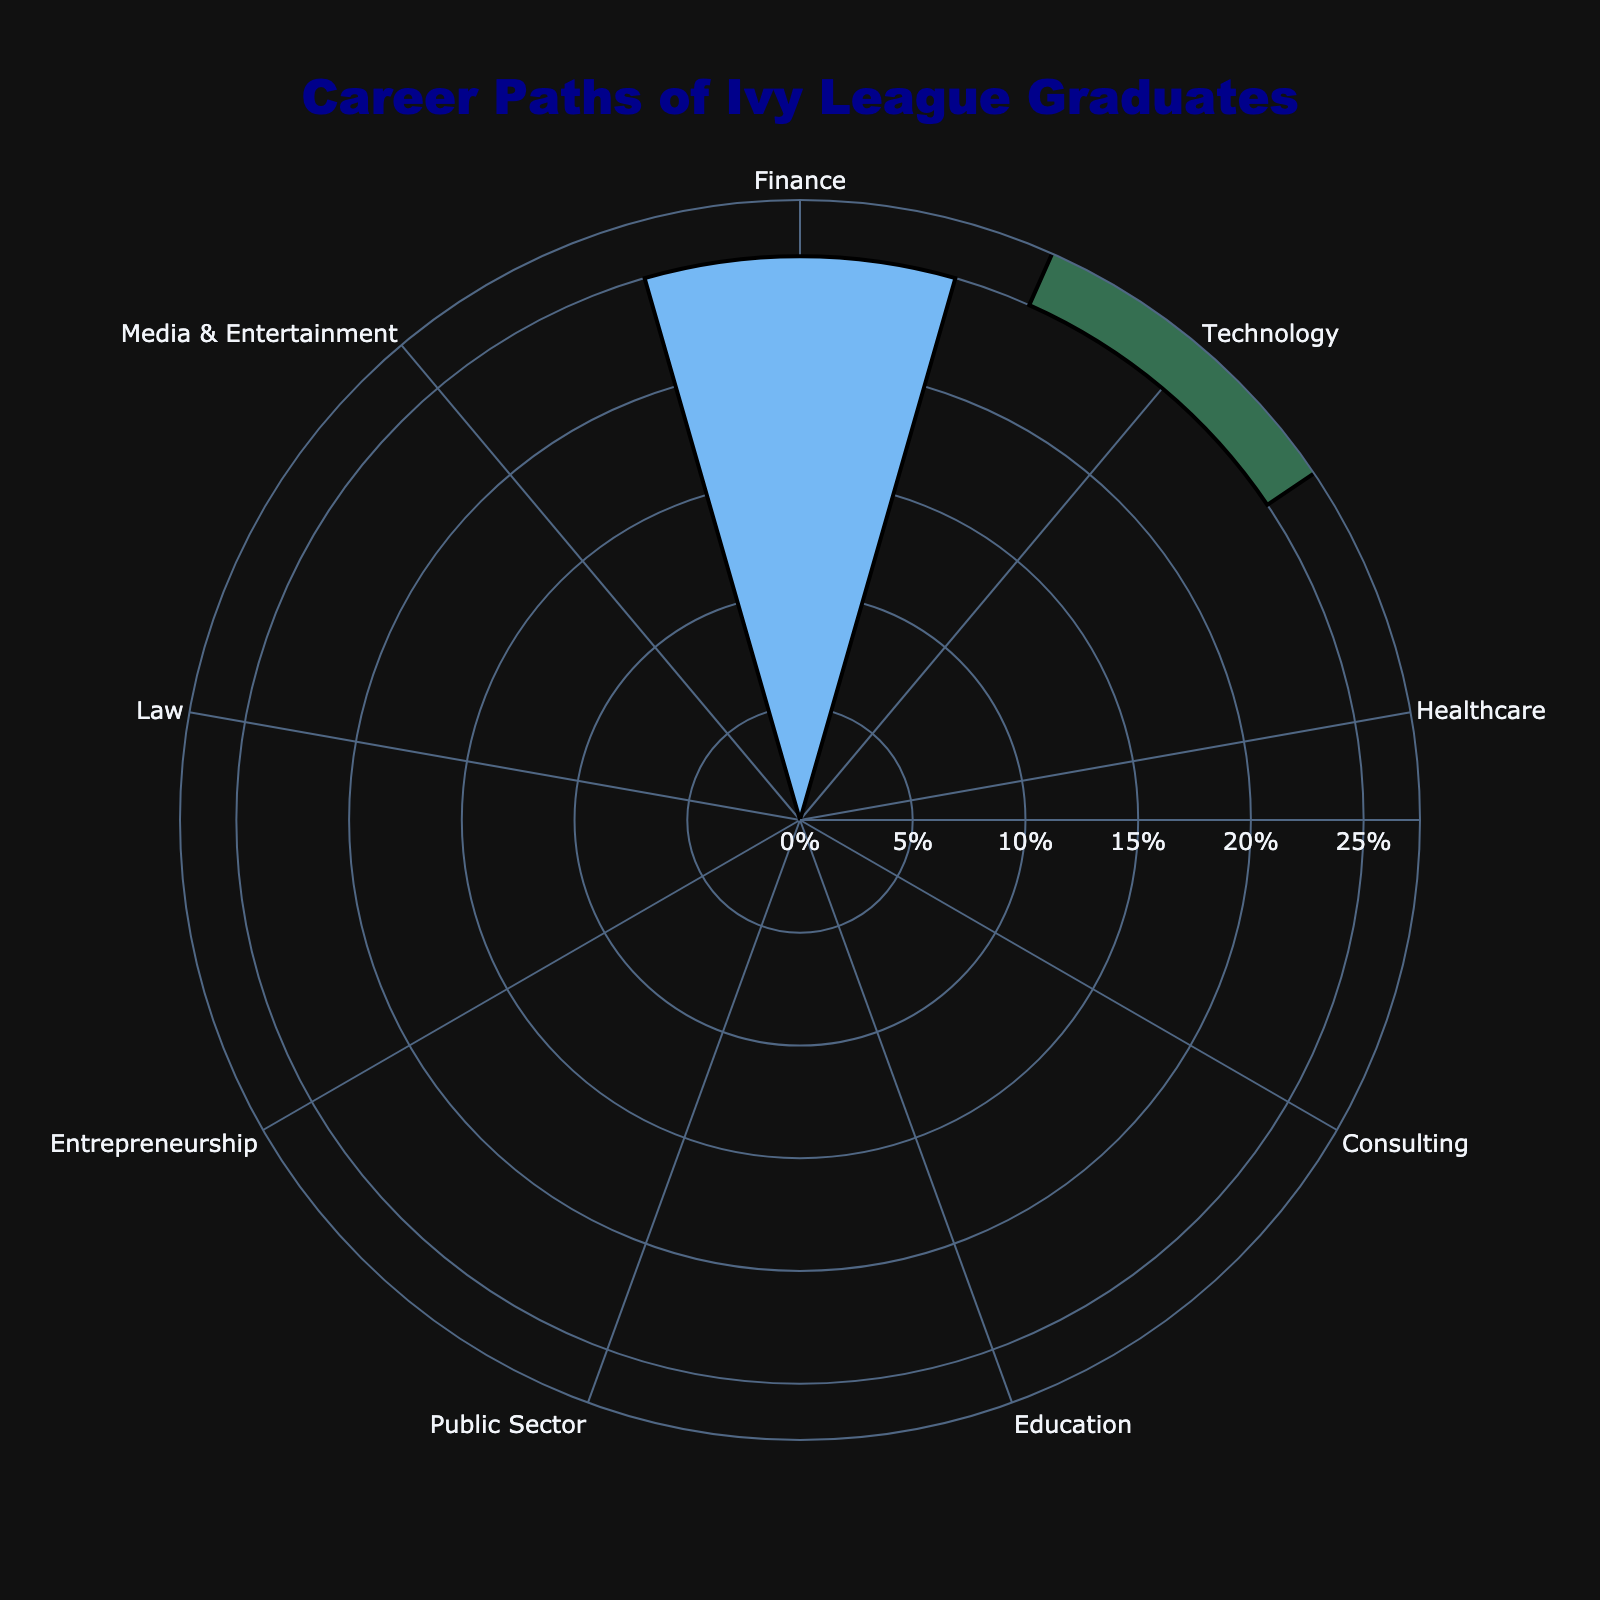What is the title of the figure? The title is located at the top of the figure. By reading it, we can understand that it highlights the focus of the chart.
Answer: Career Paths of Ivy League Graduates Which sector has the highest percentage? From the visual, the sector with the largest colored section and the highest radial value can be identified.
Answer: Finance How many sectors are represented in the figure? Counting the labeled segments that represent different sectors, we can tally up the total number.
Answer: 9 Which sector has the smallest percentage? By identifying the sector with the smallest radial value and width, we find the sector occupying the least area.
Answer: Media & Entertainment How much more percentage does Finance have compared to Education? Subtract the percentage of Education from that of Finance to get the difference.
Answer: 25% - 8% = 17% What is the combined percentage of Technology and Healthcare sectors? Add the percentages of the Technology and Healthcare sectors to find the total combined percentage.
Answer: 20% + 15% = 35% By how much does the percentage of Consulting exceed the percentage of Law? Subtract Law's percentage from Consulting's percentage to find the difference.
Answer: 10% - 5% = 5% Which sectors have a percentage greater than or equal to 10%? Identify and list all sectors whose percentage values are 10% or higher.
Answer: Finance, Technology, Healthcare, Consulting What is the total percentage represented by Education, Public Sector, and Entrepreneurship combined? Sum the percentages of the Education, Public Sector, and Entrepreneurship sectors to get the total.
Answer: 8% + 7% + 6% = 21% 